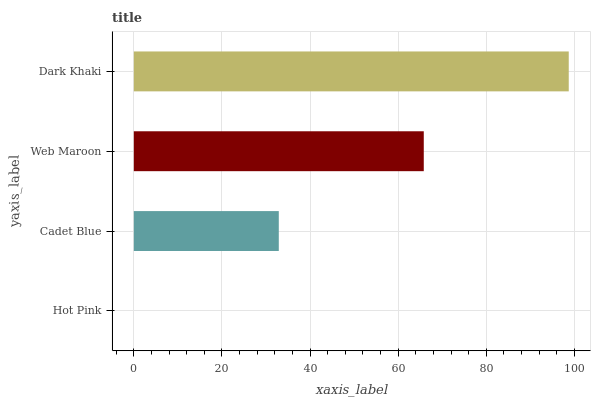Is Hot Pink the minimum?
Answer yes or no. Yes. Is Dark Khaki the maximum?
Answer yes or no. Yes. Is Cadet Blue the minimum?
Answer yes or no. No. Is Cadet Blue the maximum?
Answer yes or no. No. Is Cadet Blue greater than Hot Pink?
Answer yes or no. Yes. Is Hot Pink less than Cadet Blue?
Answer yes or no. Yes. Is Hot Pink greater than Cadet Blue?
Answer yes or no. No. Is Cadet Blue less than Hot Pink?
Answer yes or no. No. Is Web Maroon the high median?
Answer yes or no. Yes. Is Cadet Blue the low median?
Answer yes or no. Yes. Is Cadet Blue the high median?
Answer yes or no. No. Is Web Maroon the low median?
Answer yes or no. No. 